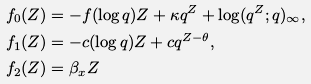Convert formula to latex. <formula><loc_0><loc_0><loc_500><loc_500>f _ { 0 } ( Z ) & = - f ( \log q ) Z + \kappa q ^ { Z } + \log ( q ^ { Z } ; q ) _ { \infty } , \\ f _ { 1 } ( Z ) & = - c ( \log q ) Z + c q ^ { Z - \theta } , \\ f _ { 2 } ( Z ) & = \beta _ { x } Z</formula> 